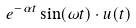Convert formula to latex. <formula><loc_0><loc_0><loc_500><loc_500>e ^ { - \alpha t } \sin ( \omega t ) \cdot u ( t )</formula> 